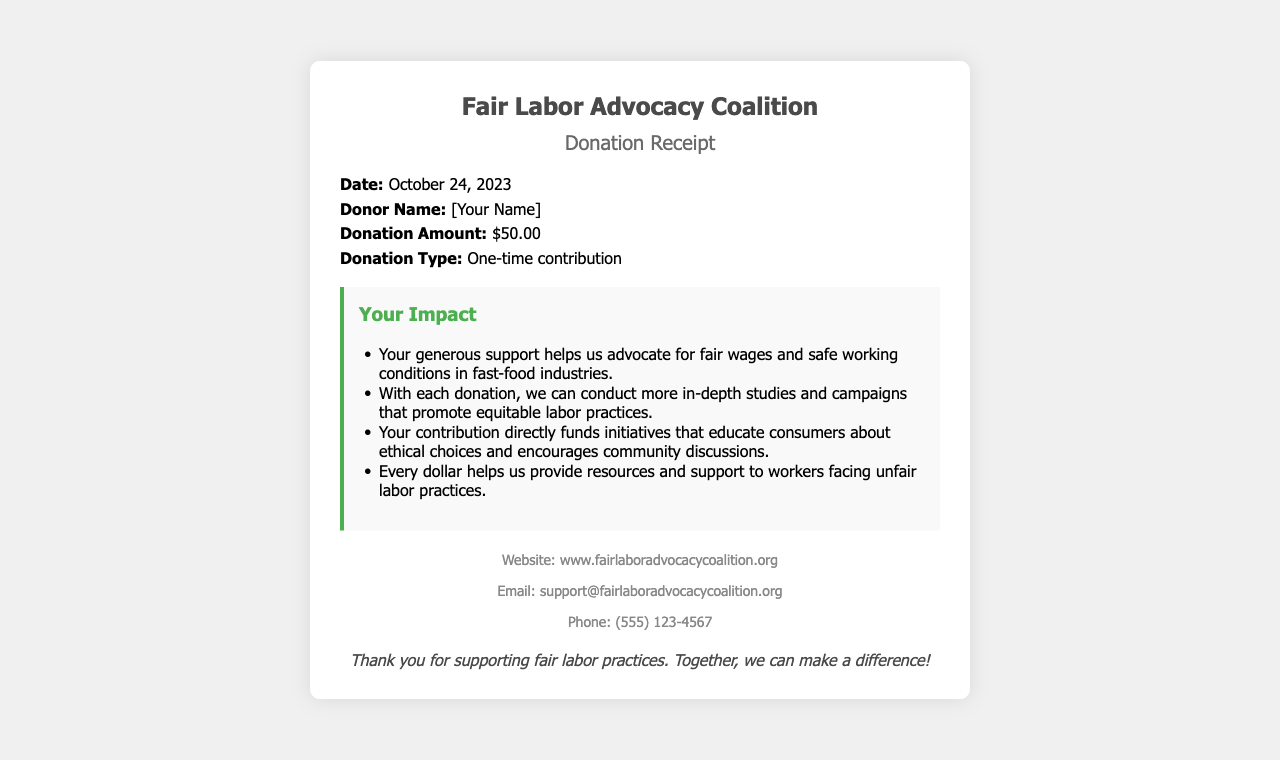What is the donation amount? The donation amount is clearly stated in the document under 'Donation Amount'.
Answer: $50.00 Who is the donor? The donor's name is labeled as 'Donor Name' in the details section of the receipt.
Answer: [Your Name] What type of donation is this? The type of donation is specified as 'Donation Type' in the receipt.
Answer: One-time contribution When was the donation made? The date of the donation is mentioned under 'Date' in the details section of the document.
Answer: October 24, 2023 What organization is this receipt from? The organization name is located at the top of the receipt.
Answer: Fair Labor Advocacy Coalition What impact does the contribution have? This question requires reasoning about the purpose of the contribution stated in the impact section of the document.
Answer: Advocates for fair wages and safe working conditions How can I contact the organization? Contact information is provided towards the end of the receipt, detailing how to reach them.
Answer: support@fairlaboradvocacycoalition.org What is the website of the organization? The website is included in the contact section of the receipt.
Answer: www.fairlaboradvocacycoalition.org What is the phone number for the organization? The phone number is listed in the contact details section of the document.
Answer: (555) 123-4567 